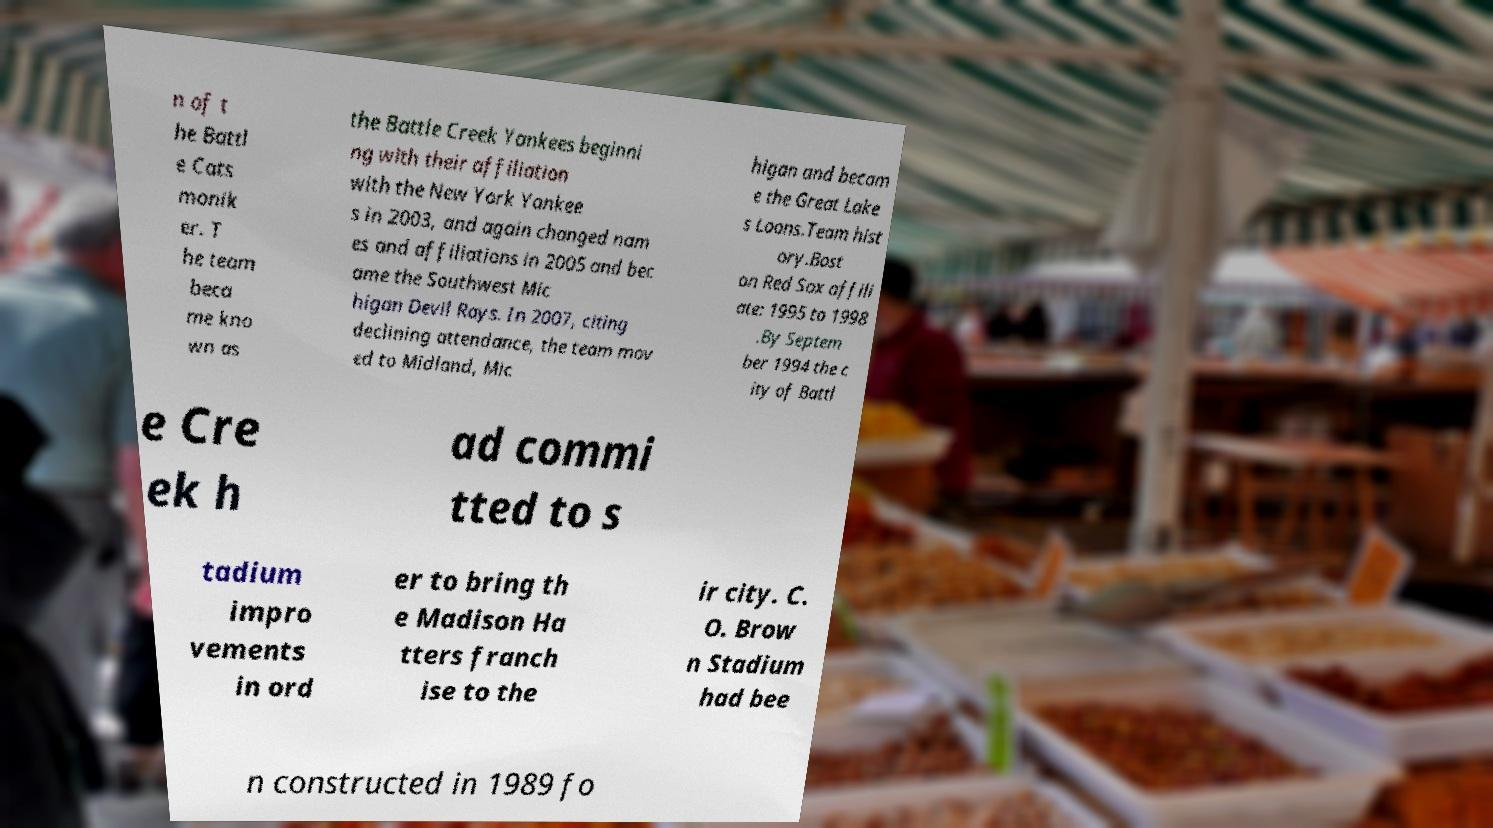There's text embedded in this image that I need extracted. Can you transcribe it verbatim? n of t he Battl e Cats monik er. T he team beca me kno wn as the Battle Creek Yankees beginni ng with their affiliation with the New York Yankee s in 2003, and again changed nam es and affiliations in 2005 and bec ame the Southwest Mic higan Devil Rays. In 2007, citing declining attendance, the team mov ed to Midland, Mic higan and becam e the Great Lake s Loons.Team hist ory.Bost on Red Sox affili ate: 1995 to 1998 .By Septem ber 1994 the c ity of Battl e Cre ek h ad commi tted to s tadium impro vements in ord er to bring th e Madison Ha tters franch ise to the ir city. C. O. Brow n Stadium had bee n constructed in 1989 fo 